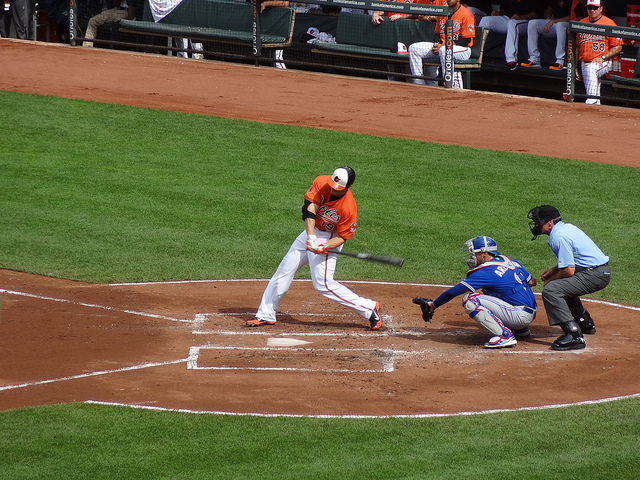What moment in baseball is being captured here? The image captures a pivotal moment in a baseball game where the batter is swinging to hit the pitch. 